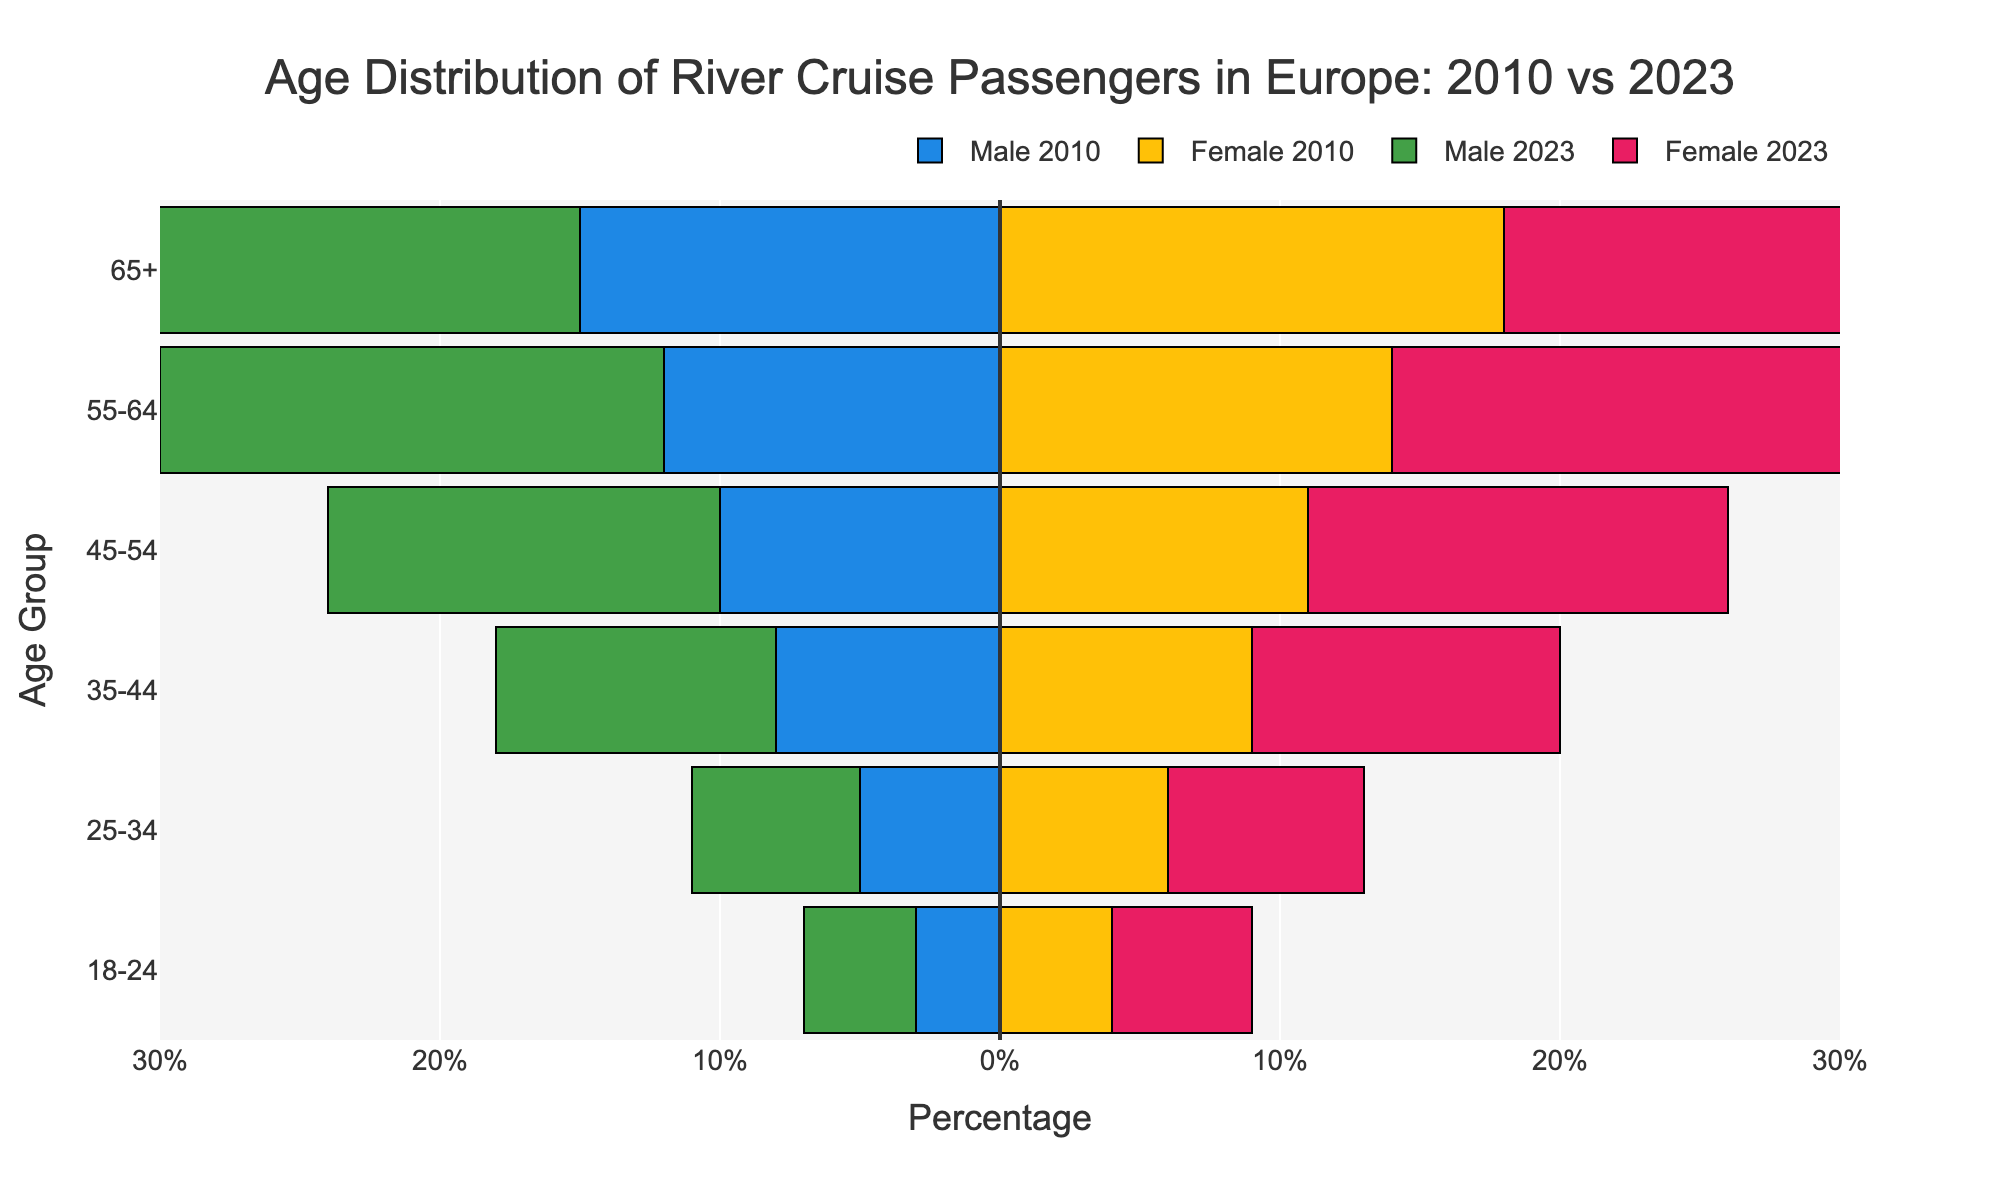How many age groups are compared in the figure? The figure shows age distributions with each bar representing a distinct age group. Count the number of distinct bars present on either side of the zero line.
Answer: 6 Which age group has the largest number of 2023 female passengers? For 2023 female passengers, identify the longest pink bar in the figure.
Answer: 65+ How does the percentage of male passengers aged 55-64 change from 2010 to 2023? Compare the bar lengths for male passengers aged 55-64, noting the change in the magnitude of the bars from 2010 to 2023.
Answer: Increased Which age group shows the most significant increase in total passenger percentage from 2010 to 2023? Calculate the percentage increase for each age group by subtracting the values of 2010 male and female percentages from those of 2023 male and female percentages and identify the group with the highest difference.
Answer: 65+ How does the gender distribution differ in the age group 25-34 from 2010 to 2023? Compare the lengths of the bars for males and females in the age group 25-34 for both years, noting any changes in proportions between genders.
Answer: Both increased, but males less than females What is the combined percentage of passengers (both male and female) aged 35-44 in 2023? Sum the percentages of 2023 male and female passengers in the age group 35-44.
Answer: 21% In which age group is the proportion of male to female passengers the closest to equal in 2023? Identify the age group where the lengths of the green (male) and pink (female) bars are closest to each other in 2023.
Answer: 25-34 What is the difference in the percentage of 45-54 year-old male passengers between 2010 and 2023? Subtract the percentage value of 2010 male passengers aged 45-54 from that of 2023.
Answer: 4% Which year shows a greater proportion of elderly (65+) passengers overall? Compare the total lengths of the blue and yellow bars (for 2010) against the green and pink bars (for 2023) for the 65+ age group.
Answer: 2023 What patterns or trends can you infer about the preferences of different age groups for river cruises between 2010 and 2023? Observing the changes in bar lengths over the years, notice whether increases or decreases follow certain age trends and form a general pattern about river cruise preferences.
Answer: Increase in older age groups, moderate increase in younger groups 